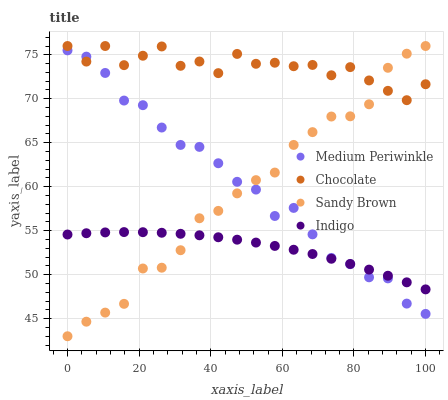Does Indigo have the minimum area under the curve?
Answer yes or no. Yes. Does Chocolate have the maximum area under the curve?
Answer yes or no. Yes. Does Medium Periwinkle have the minimum area under the curve?
Answer yes or no. No. Does Medium Periwinkle have the maximum area under the curve?
Answer yes or no. No. Is Indigo the smoothest?
Answer yes or no. Yes. Is Chocolate the roughest?
Answer yes or no. Yes. Is Medium Periwinkle the smoothest?
Answer yes or no. No. Is Medium Periwinkle the roughest?
Answer yes or no. No. Does Sandy Brown have the lowest value?
Answer yes or no. Yes. Does Medium Periwinkle have the lowest value?
Answer yes or no. No. Does Chocolate have the highest value?
Answer yes or no. Yes. Does Medium Periwinkle have the highest value?
Answer yes or no. No. Is Indigo less than Chocolate?
Answer yes or no. Yes. Is Chocolate greater than Indigo?
Answer yes or no. Yes. Does Chocolate intersect Sandy Brown?
Answer yes or no. Yes. Is Chocolate less than Sandy Brown?
Answer yes or no. No. Is Chocolate greater than Sandy Brown?
Answer yes or no. No. Does Indigo intersect Chocolate?
Answer yes or no. No. 